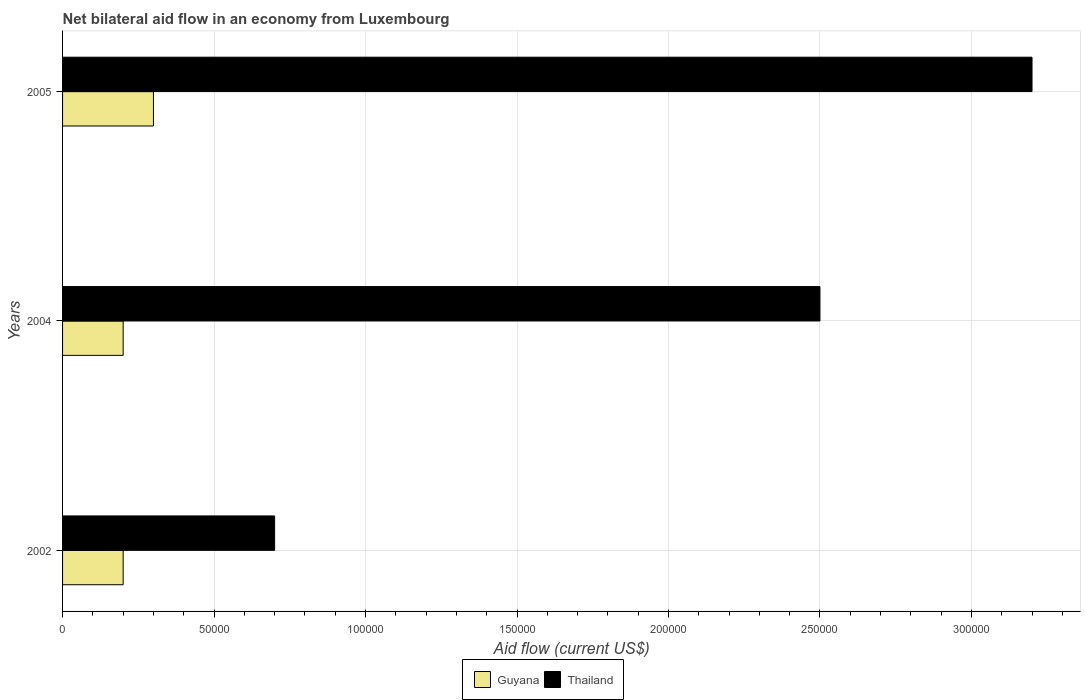How many groups of bars are there?
Offer a terse response. 3. In how many cases, is the number of bars for a given year not equal to the number of legend labels?
Ensure brevity in your answer.  0. Across all years, what is the maximum net bilateral aid flow in Guyana?
Keep it short and to the point. 3.00e+04. Across all years, what is the minimum net bilateral aid flow in Thailand?
Give a very brief answer. 7.00e+04. What is the total net bilateral aid flow in Guyana in the graph?
Offer a terse response. 7.00e+04. What is the difference between the net bilateral aid flow in Thailand in 2004 and that in 2005?
Provide a succinct answer. -7.00e+04. What is the difference between the net bilateral aid flow in Thailand in 2004 and the net bilateral aid flow in Guyana in 2005?
Offer a very short reply. 2.20e+05. What is the average net bilateral aid flow in Thailand per year?
Your answer should be compact. 2.13e+05. In the year 2002, what is the difference between the net bilateral aid flow in Thailand and net bilateral aid flow in Guyana?
Your answer should be compact. 5.00e+04. In how many years, is the net bilateral aid flow in Guyana greater than 70000 US$?
Make the answer very short. 0. What is the ratio of the net bilateral aid flow in Guyana in 2004 to that in 2005?
Provide a short and direct response. 0.67. Is the net bilateral aid flow in Thailand in 2002 less than that in 2005?
Provide a succinct answer. Yes. What does the 1st bar from the top in 2005 represents?
Make the answer very short. Thailand. What does the 2nd bar from the bottom in 2005 represents?
Make the answer very short. Thailand. How many years are there in the graph?
Provide a short and direct response. 3. What is the difference between two consecutive major ticks on the X-axis?
Provide a short and direct response. 5.00e+04. Does the graph contain any zero values?
Your response must be concise. No. How many legend labels are there?
Offer a terse response. 2. How are the legend labels stacked?
Give a very brief answer. Horizontal. What is the title of the graph?
Your response must be concise. Net bilateral aid flow in an economy from Luxembourg. What is the label or title of the X-axis?
Your answer should be very brief. Aid flow (current US$). What is the label or title of the Y-axis?
Ensure brevity in your answer.  Years. What is the Aid flow (current US$) in Thailand in 2002?
Give a very brief answer. 7.00e+04. What is the Aid flow (current US$) in Guyana in 2005?
Provide a succinct answer. 3.00e+04. What is the Aid flow (current US$) of Thailand in 2005?
Ensure brevity in your answer.  3.20e+05. Across all years, what is the maximum Aid flow (current US$) in Guyana?
Offer a very short reply. 3.00e+04. What is the total Aid flow (current US$) in Thailand in the graph?
Your response must be concise. 6.40e+05. What is the difference between the Aid flow (current US$) of Thailand in 2002 and that in 2004?
Make the answer very short. -1.80e+05. What is the difference between the Aid flow (current US$) of Guyana in 2002 and that in 2005?
Make the answer very short. -10000. What is the difference between the Aid flow (current US$) in Guyana in 2002 and the Aid flow (current US$) in Thailand in 2005?
Offer a terse response. -3.00e+05. What is the average Aid flow (current US$) of Guyana per year?
Keep it short and to the point. 2.33e+04. What is the average Aid flow (current US$) in Thailand per year?
Offer a terse response. 2.13e+05. What is the ratio of the Aid flow (current US$) in Guyana in 2002 to that in 2004?
Offer a very short reply. 1. What is the ratio of the Aid flow (current US$) in Thailand in 2002 to that in 2004?
Ensure brevity in your answer.  0.28. What is the ratio of the Aid flow (current US$) of Thailand in 2002 to that in 2005?
Give a very brief answer. 0.22. What is the ratio of the Aid flow (current US$) in Guyana in 2004 to that in 2005?
Your answer should be very brief. 0.67. What is the ratio of the Aid flow (current US$) of Thailand in 2004 to that in 2005?
Provide a short and direct response. 0.78. What is the difference between the highest and the second highest Aid flow (current US$) of Guyana?
Give a very brief answer. 10000. What is the difference between the highest and the lowest Aid flow (current US$) in Guyana?
Give a very brief answer. 10000. What is the difference between the highest and the lowest Aid flow (current US$) of Thailand?
Offer a very short reply. 2.50e+05. 